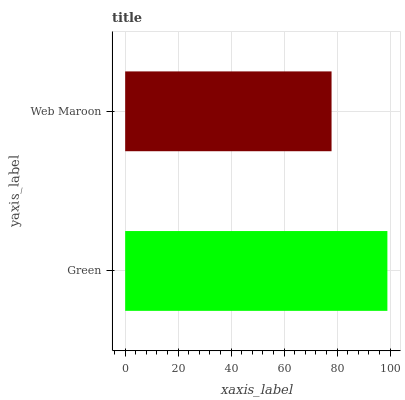Is Web Maroon the minimum?
Answer yes or no. Yes. Is Green the maximum?
Answer yes or no. Yes. Is Web Maroon the maximum?
Answer yes or no. No. Is Green greater than Web Maroon?
Answer yes or no. Yes. Is Web Maroon less than Green?
Answer yes or no. Yes. Is Web Maroon greater than Green?
Answer yes or no. No. Is Green less than Web Maroon?
Answer yes or no. No. Is Green the high median?
Answer yes or no. Yes. Is Web Maroon the low median?
Answer yes or no. Yes. Is Web Maroon the high median?
Answer yes or no. No. Is Green the low median?
Answer yes or no. No. 